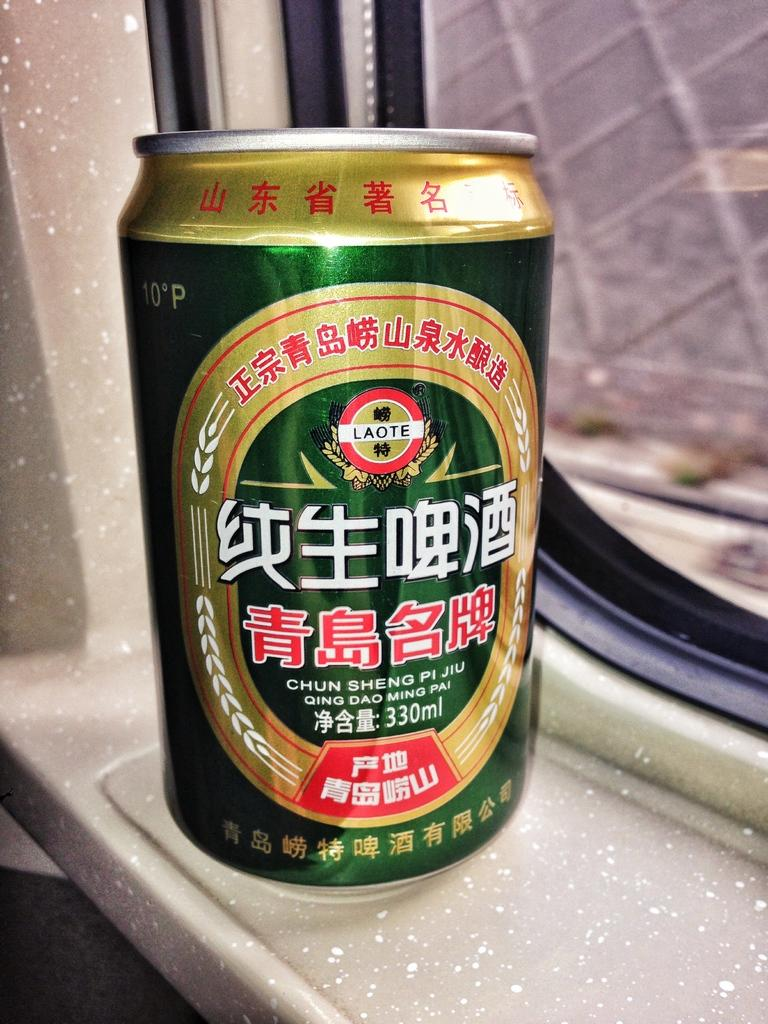<image>
Summarize the visual content of the image. A can of Chun Sheng Pi Ju drink is sitting on a window sill. 